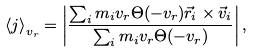Convert formula to latex. <formula><loc_0><loc_0><loc_500><loc_500>\left < j \right > _ { v _ { r } } = \left | \frac { \sum _ { i } m _ { i } v _ { r } \Theta ( - v _ { r } ) \vec { r } _ { i } \times \vec { v } _ { i } } { \sum _ { i } m _ { i } v _ { r } \Theta ( - v _ { r } ) } \right | ,</formula> 